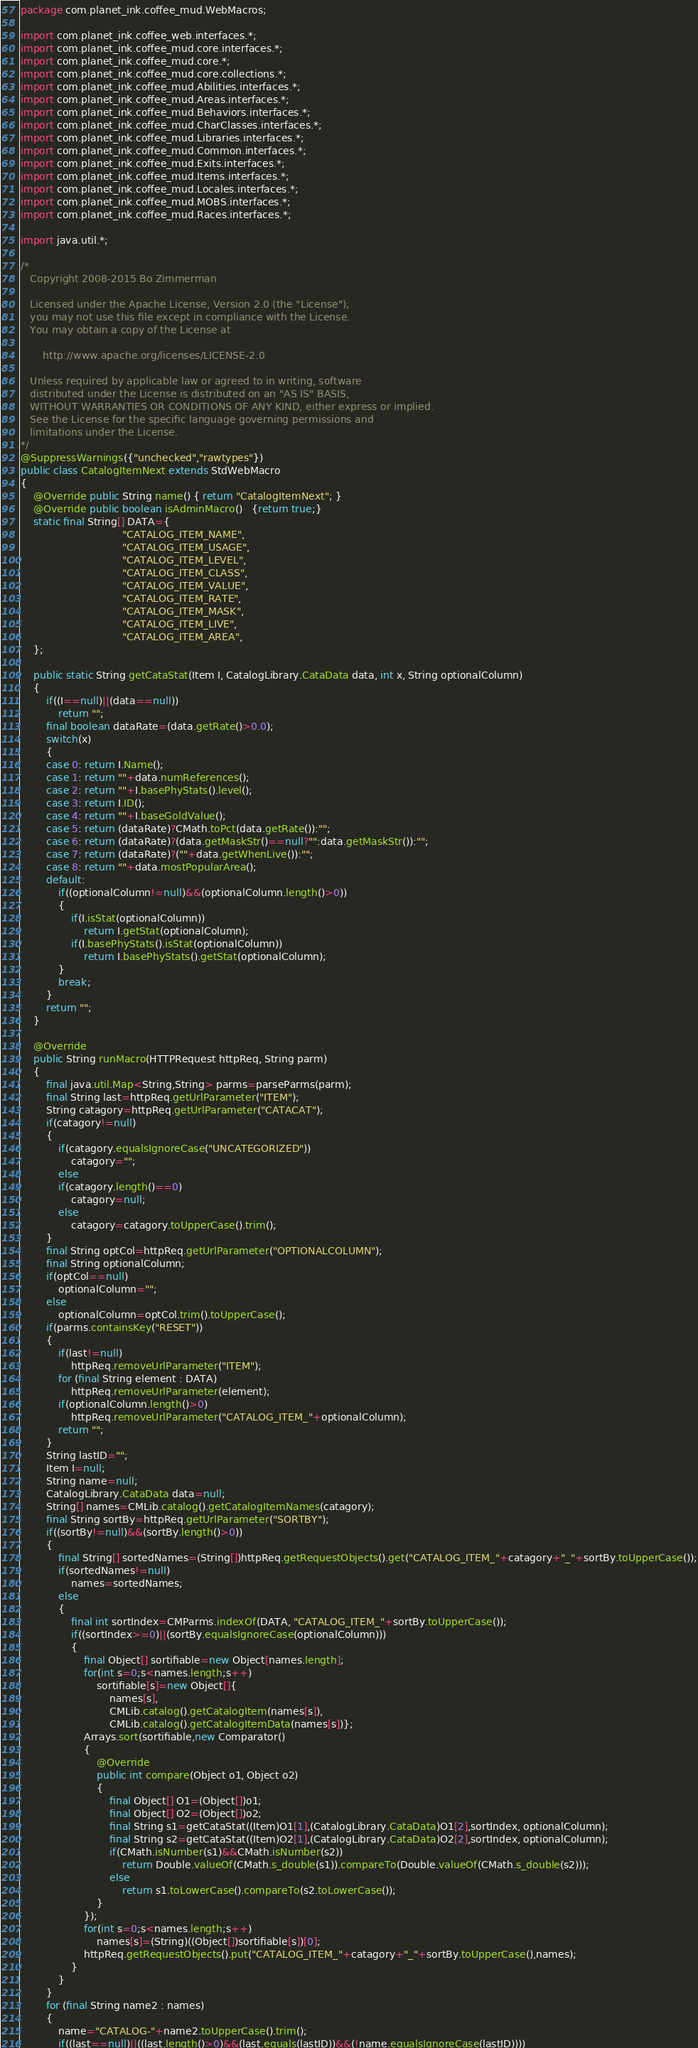<code> <loc_0><loc_0><loc_500><loc_500><_Java_>package com.planet_ink.coffee_mud.WebMacros;

import com.planet_ink.coffee_web.interfaces.*;
import com.planet_ink.coffee_mud.core.interfaces.*;
import com.planet_ink.coffee_mud.core.*;
import com.planet_ink.coffee_mud.core.collections.*;
import com.planet_ink.coffee_mud.Abilities.interfaces.*;
import com.planet_ink.coffee_mud.Areas.interfaces.*;
import com.planet_ink.coffee_mud.Behaviors.interfaces.*;
import com.planet_ink.coffee_mud.CharClasses.interfaces.*;
import com.planet_ink.coffee_mud.Libraries.interfaces.*;
import com.planet_ink.coffee_mud.Common.interfaces.*;
import com.planet_ink.coffee_mud.Exits.interfaces.*;
import com.planet_ink.coffee_mud.Items.interfaces.*;
import com.planet_ink.coffee_mud.Locales.interfaces.*;
import com.planet_ink.coffee_mud.MOBS.interfaces.*;
import com.planet_ink.coffee_mud.Races.interfaces.*;

import java.util.*;

/*
   Copyright 2008-2015 Bo Zimmerman

   Licensed under the Apache License, Version 2.0 (the "License");
   you may not use this file except in compliance with the License.
   You may obtain a copy of the License at

	   http://www.apache.org/licenses/LICENSE-2.0

   Unless required by applicable law or agreed to in writing, software
   distributed under the License is distributed on an "AS IS" BASIS,
   WITHOUT WARRANTIES OR CONDITIONS OF ANY KIND, either express or implied.
   See the License for the specific language governing permissions and
   limitations under the License.
*/
@SuppressWarnings({"unchecked","rawtypes"})
public class CatalogItemNext extends StdWebMacro
{
	@Override public String name() { return "CatalogItemNext"; }
	@Override public boolean isAdminMacro()   {return true;}
	static final String[] DATA={
								"CATALOG_ITEM_NAME",
								"CATALOG_ITEM_USAGE",
								"CATALOG_ITEM_LEVEL",
								"CATALOG_ITEM_CLASS",
								"CATALOG_ITEM_VALUE",
								"CATALOG_ITEM_RATE",
								"CATALOG_ITEM_MASK",
								"CATALOG_ITEM_LIVE",
								"CATALOG_ITEM_AREA",
	};

	public static String getCataStat(Item I, CatalogLibrary.CataData data, int x, String optionalColumn)
	{
		if((I==null)||(data==null))
			return "";
		final boolean dataRate=(data.getRate()>0.0);
		switch(x)
		{
		case 0: return I.Name();
		case 1: return ""+data.numReferences();
		case 2: return ""+I.basePhyStats().level();
		case 3: return I.ID();
		case 4: return ""+I.baseGoldValue();
		case 5: return (dataRate)?CMath.toPct(data.getRate()):"";
		case 6: return (dataRate)?(data.getMaskStr()==null?"":data.getMaskStr()):"";
		case 7: return (dataRate)?(""+data.getWhenLive()):"";
		case 8: return ""+data.mostPopularArea();
		default:
			if((optionalColumn!=null)&&(optionalColumn.length()>0))
			{
				if(I.isStat(optionalColumn))
					return I.getStat(optionalColumn);
				if(I.basePhyStats().isStat(optionalColumn))
					return I.basePhyStats().getStat(optionalColumn);
			}
			break;
		}
		return "";
	}

	@Override
	public String runMacro(HTTPRequest httpReq, String parm)
	{
		final java.util.Map<String,String> parms=parseParms(parm);
		final String last=httpReq.getUrlParameter("ITEM");
		String catagory=httpReq.getUrlParameter("CATACAT");
		if(catagory!=null)
		{
			if(catagory.equalsIgnoreCase("UNCATEGORIZED"))
				catagory="";
			else
			if(catagory.length()==0)
				catagory=null;
			else
				catagory=catagory.toUpperCase().trim();
		}
		final String optCol=httpReq.getUrlParameter("OPTIONALCOLUMN");
		final String optionalColumn;
		if(optCol==null)
			optionalColumn="";
		else
			optionalColumn=optCol.trim().toUpperCase();
		if(parms.containsKey("RESET"))
		{
			if(last!=null)
				httpReq.removeUrlParameter("ITEM");
			for (final String element : DATA)
				httpReq.removeUrlParameter(element);
			if(optionalColumn.length()>0)
				httpReq.removeUrlParameter("CATALOG_ITEM_"+optionalColumn);
			return "";
		}
		String lastID="";
		Item I=null;
		String name=null;
		CatalogLibrary.CataData data=null;
		String[] names=CMLib.catalog().getCatalogItemNames(catagory);
		final String sortBy=httpReq.getUrlParameter("SORTBY");
		if((sortBy!=null)&&(sortBy.length()>0))
		{
			final String[] sortedNames=(String[])httpReq.getRequestObjects().get("CATALOG_ITEM_"+catagory+"_"+sortBy.toUpperCase());
			if(sortedNames!=null)
				names=sortedNames;
			else
			{
				final int sortIndex=CMParms.indexOf(DATA, "CATALOG_ITEM_"+sortBy.toUpperCase());
				if((sortIndex>=0)||(sortBy.equalsIgnoreCase(optionalColumn)))
				{
					final Object[] sortifiable=new Object[names.length];
					for(int s=0;s<names.length;s++)
						sortifiable[s]=new Object[]{
							names[s],
							CMLib.catalog().getCatalogItem(names[s]),
							CMLib.catalog().getCatalogItemData(names[s])};
					Arrays.sort(sortifiable,new Comparator()
					{
						@Override
						public int compare(Object o1, Object o2)
						{
							final Object[] O1=(Object[])o1;
							final Object[] O2=(Object[])o2;
							final String s1=getCataStat((Item)O1[1],(CatalogLibrary.CataData)O1[2],sortIndex, optionalColumn);
							final String s2=getCataStat((Item)O2[1],(CatalogLibrary.CataData)O2[2],sortIndex, optionalColumn);
							if(CMath.isNumber(s1)&&CMath.isNumber(s2))
								return Double.valueOf(CMath.s_double(s1)).compareTo(Double.valueOf(CMath.s_double(s2)));
							else
								return s1.toLowerCase().compareTo(s2.toLowerCase());
						}
					});
					for(int s=0;s<names.length;s++)
						names[s]=(String)((Object[])sortifiable[s])[0];
					httpReq.getRequestObjects().put("CATALOG_ITEM_"+catagory+"_"+sortBy.toUpperCase(),names);
				}
			}
		}
		for (final String name2 : names)
		{
			name="CATALOG-"+name2.toUpperCase().trim();
			if((last==null)||((last.length()>0)&&(last.equals(lastID))&&(!name.equalsIgnoreCase(lastID))))</code> 